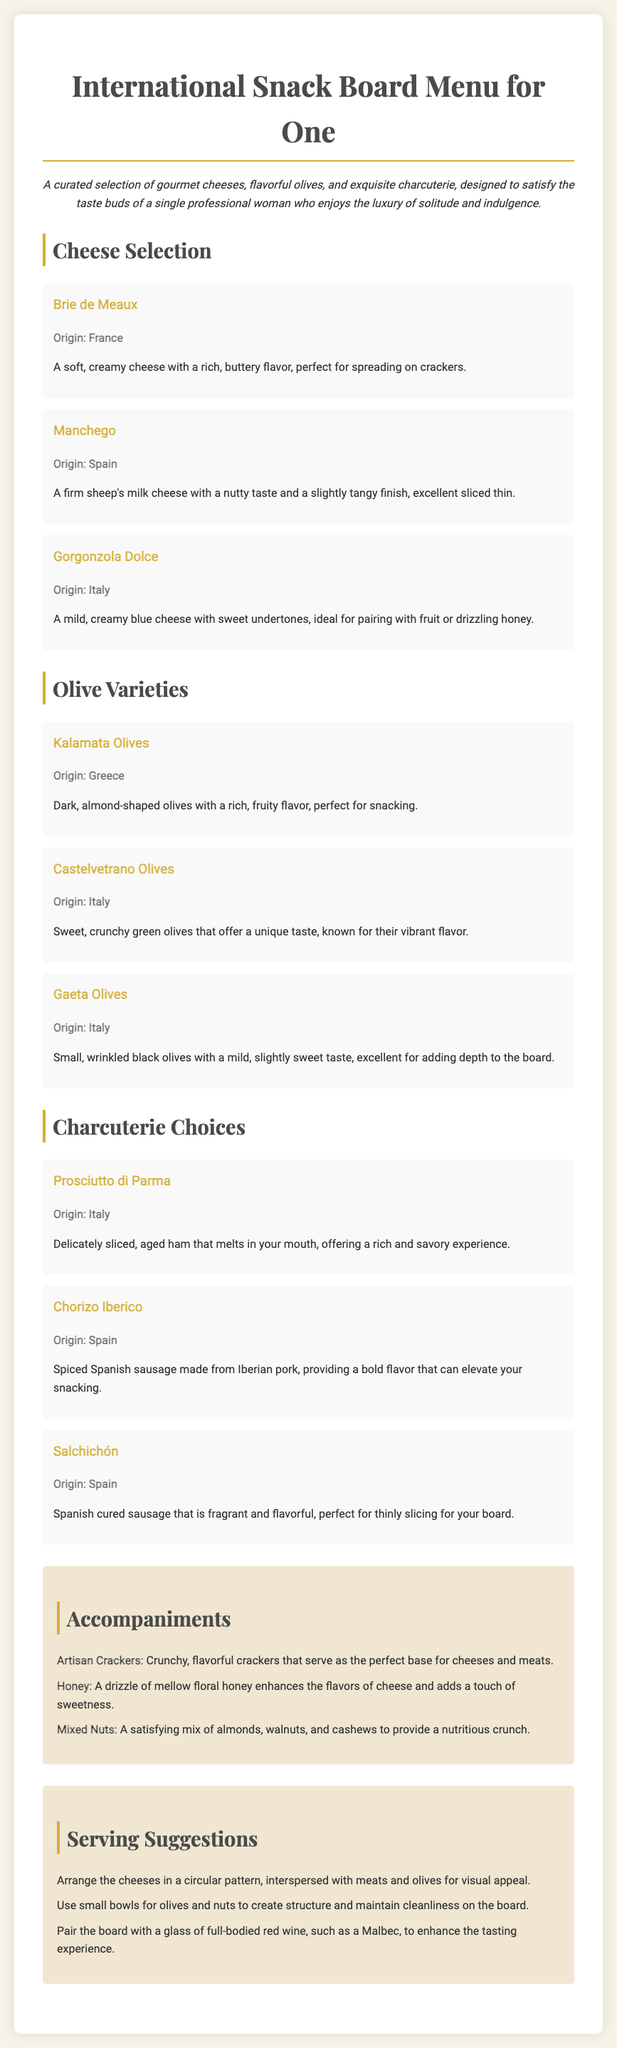What is the title of the menu? The title of the menu is prominently displayed at the top of the document, which introduces the theme of the selection.
Answer: International Snack Board Menu for One Which cheese originates from France? The document lists various cheeses with their origins, and the cheese specified with France is Brie de Meaux.
Answer: Brie de Meaux What type of olives are known for their sweet, crunchy texture? The document describes this unique characteristic of a certain type of olive, specifically highlighting their taste and texture.
Answer: Castelvetrano Olives How many charcuterie options are listed in the document? The document outlines the selection of charcuterie choices, resulting in a precise count of the options provided.
Answer: Three What is an ideal pairing suggestion for the snack board? The document recommends a complementary drink that enhances the flavors of the snacks listed on the board.
Answer: Full-bodied red wine What is the origin of Gorgonzola Dolce? The document provides specific origins for each cheese, including the one in question regarding Gorgonzola Dolce.
Answer: Italy How should the cheeses be arranged for visual appeal? The document outlines specific serving suggestions to enhance the presentation of the food items.
Answer: Circular pattern What is an accompaniment that enhances the flavors of cheese? The document lists items that serve as fine companions to cheese, including a specific sweet option.
Answer: Honey 